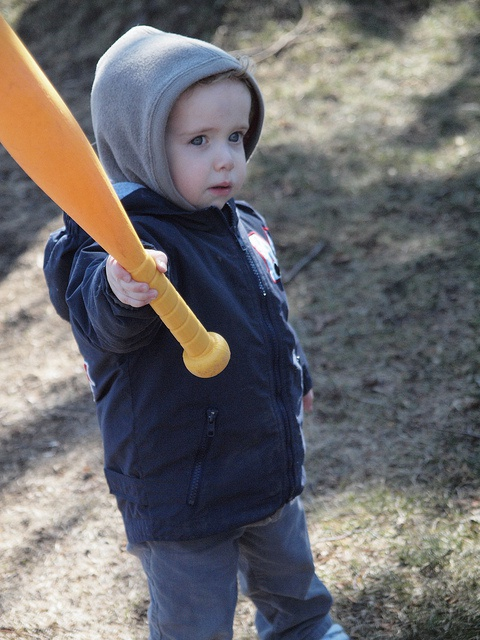Describe the objects in this image and their specific colors. I can see people in darkgray, black, navy, and gray tones and baseball bat in darkgray, tan, orange, and khaki tones in this image. 